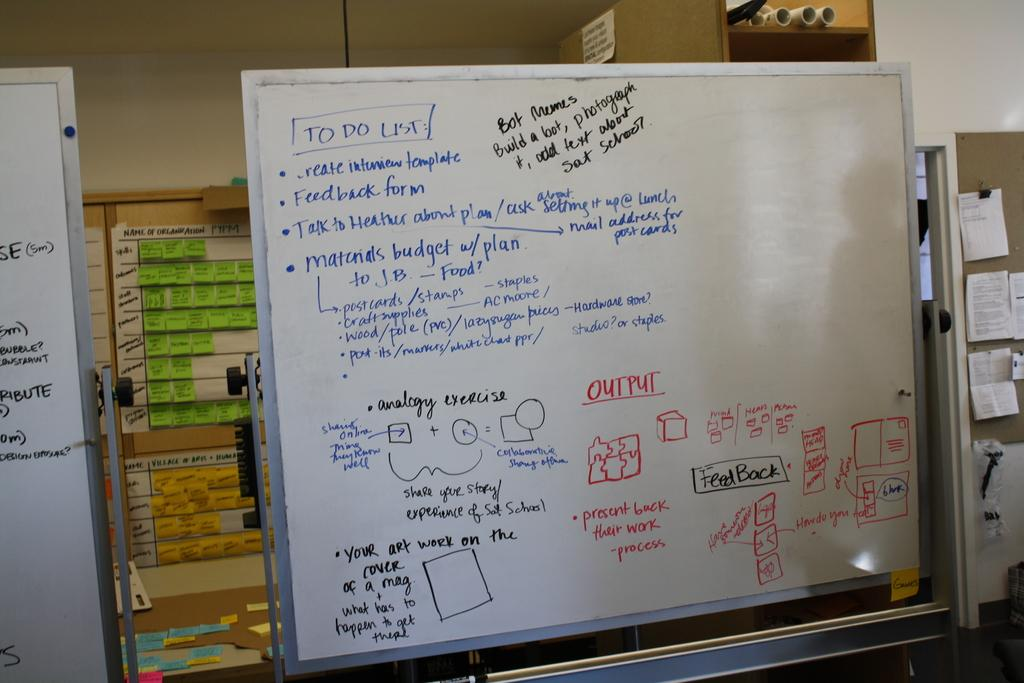Provide a one-sentence caption for the provided image. A to do list that includes a feedback form and talking to heather as well as output. 